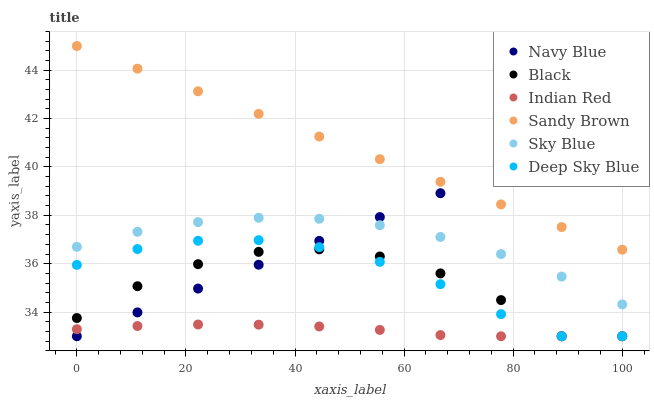Does Indian Red have the minimum area under the curve?
Answer yes or no. Yes. Does Sandy Brown have the maximum area under the curve?
Answer yes or no. Yes. Does Navy Blue have the minimum area under the curve?
Answer yes or no. No. Does Navy Blue have the maximum area under the curve?
Answer yes or no. No. Is Navy Blue the smoothest?
Answer yes or no. Yes. Is Black the roughest?
Answer yes or no. Yes. Is Black the smoothest?
Answer yes or no. No. Is Navy Blue the roughest?
Answer yes or no. No. Does Indian Red have the lowest value?
Answer yes or no. Yes. Does Sky Blue have the lowest value?
Answer yes or no. No. Does Sandy Brown have the highest value?
Answer yes or no. Yes. Does Navy Blue have the highest value?
Answer yes or no. No. Is Sky Blue less than Sandy Brown?
Answer yes or no. Yes. Is Sandy Brown greater than Sky Blue?
Answer yes or no. Yes. Does Black intersect Navy Blue?
Answer yes or no. Yes. Is Black less than Navy Blue?
Answer yes or no. No. Is Black greater than Navy Blue?
Answer yes or no. No. Does Sky Blue intersect Sandy Brown?
Answer yes or no. No. 